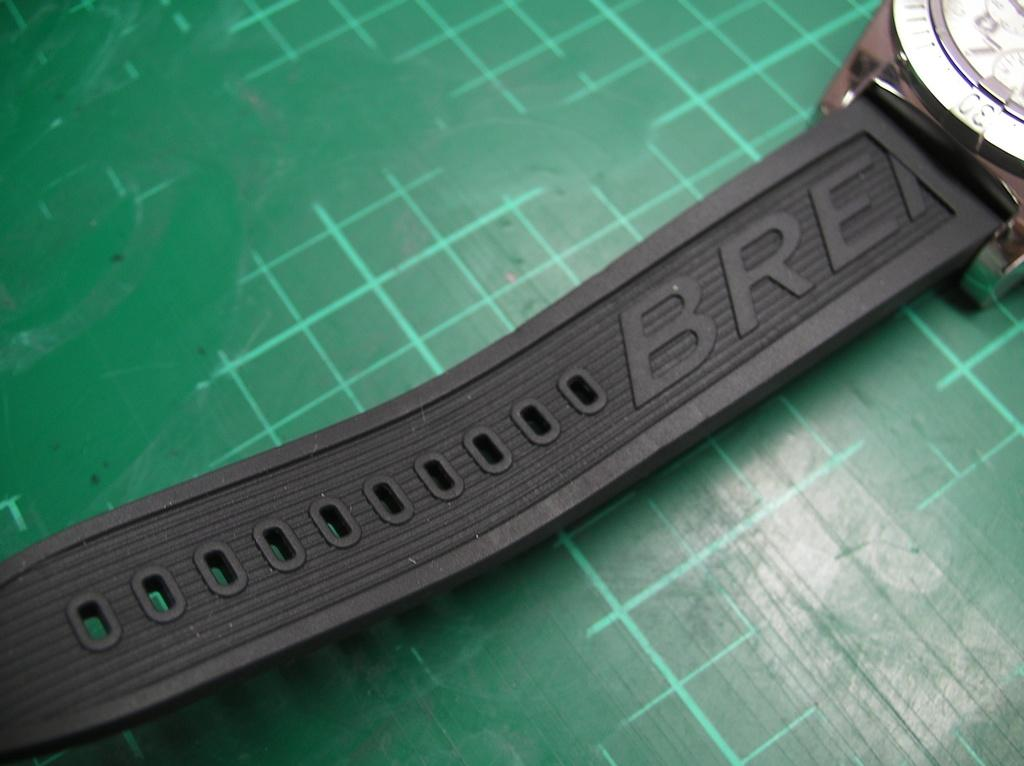Provide a one-sentence caption for the provided image. Black strap of a watch named "BRE" on a green tabletop. 